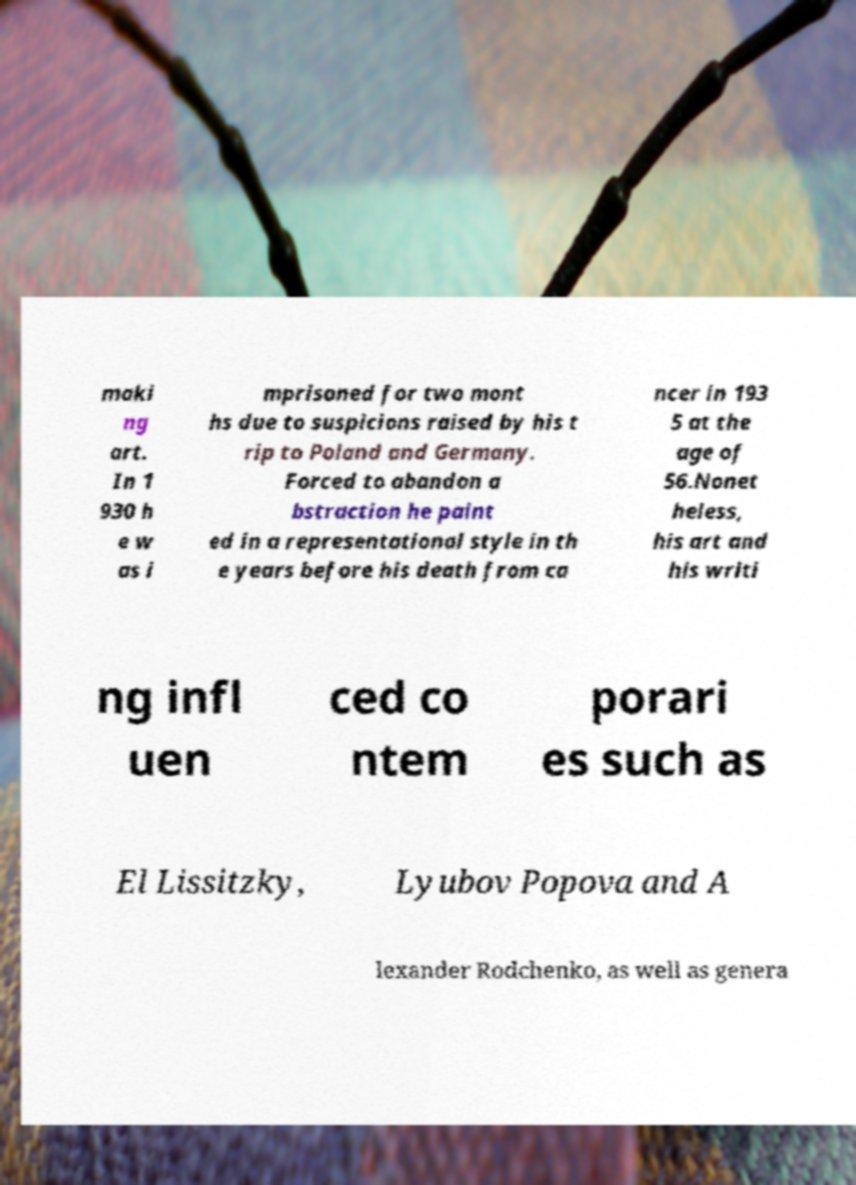Can you accurately transcribe the text from the provided image for me? maki ng art. In 1 930 h e w as i mprisoned for two mont hs due to suspicions raised by his t rip to Poland and Germany. Forced to abandon a bstraction he paint ed in a representational style in th e years before his death from ca ncer in 193 5 at the age of 56.Nonet heless, his art and his writi ng infl uen ced co ntem porari es such as El Lissitzky, Lyubov Popova and A lexander Rodchenko, as well as genera 